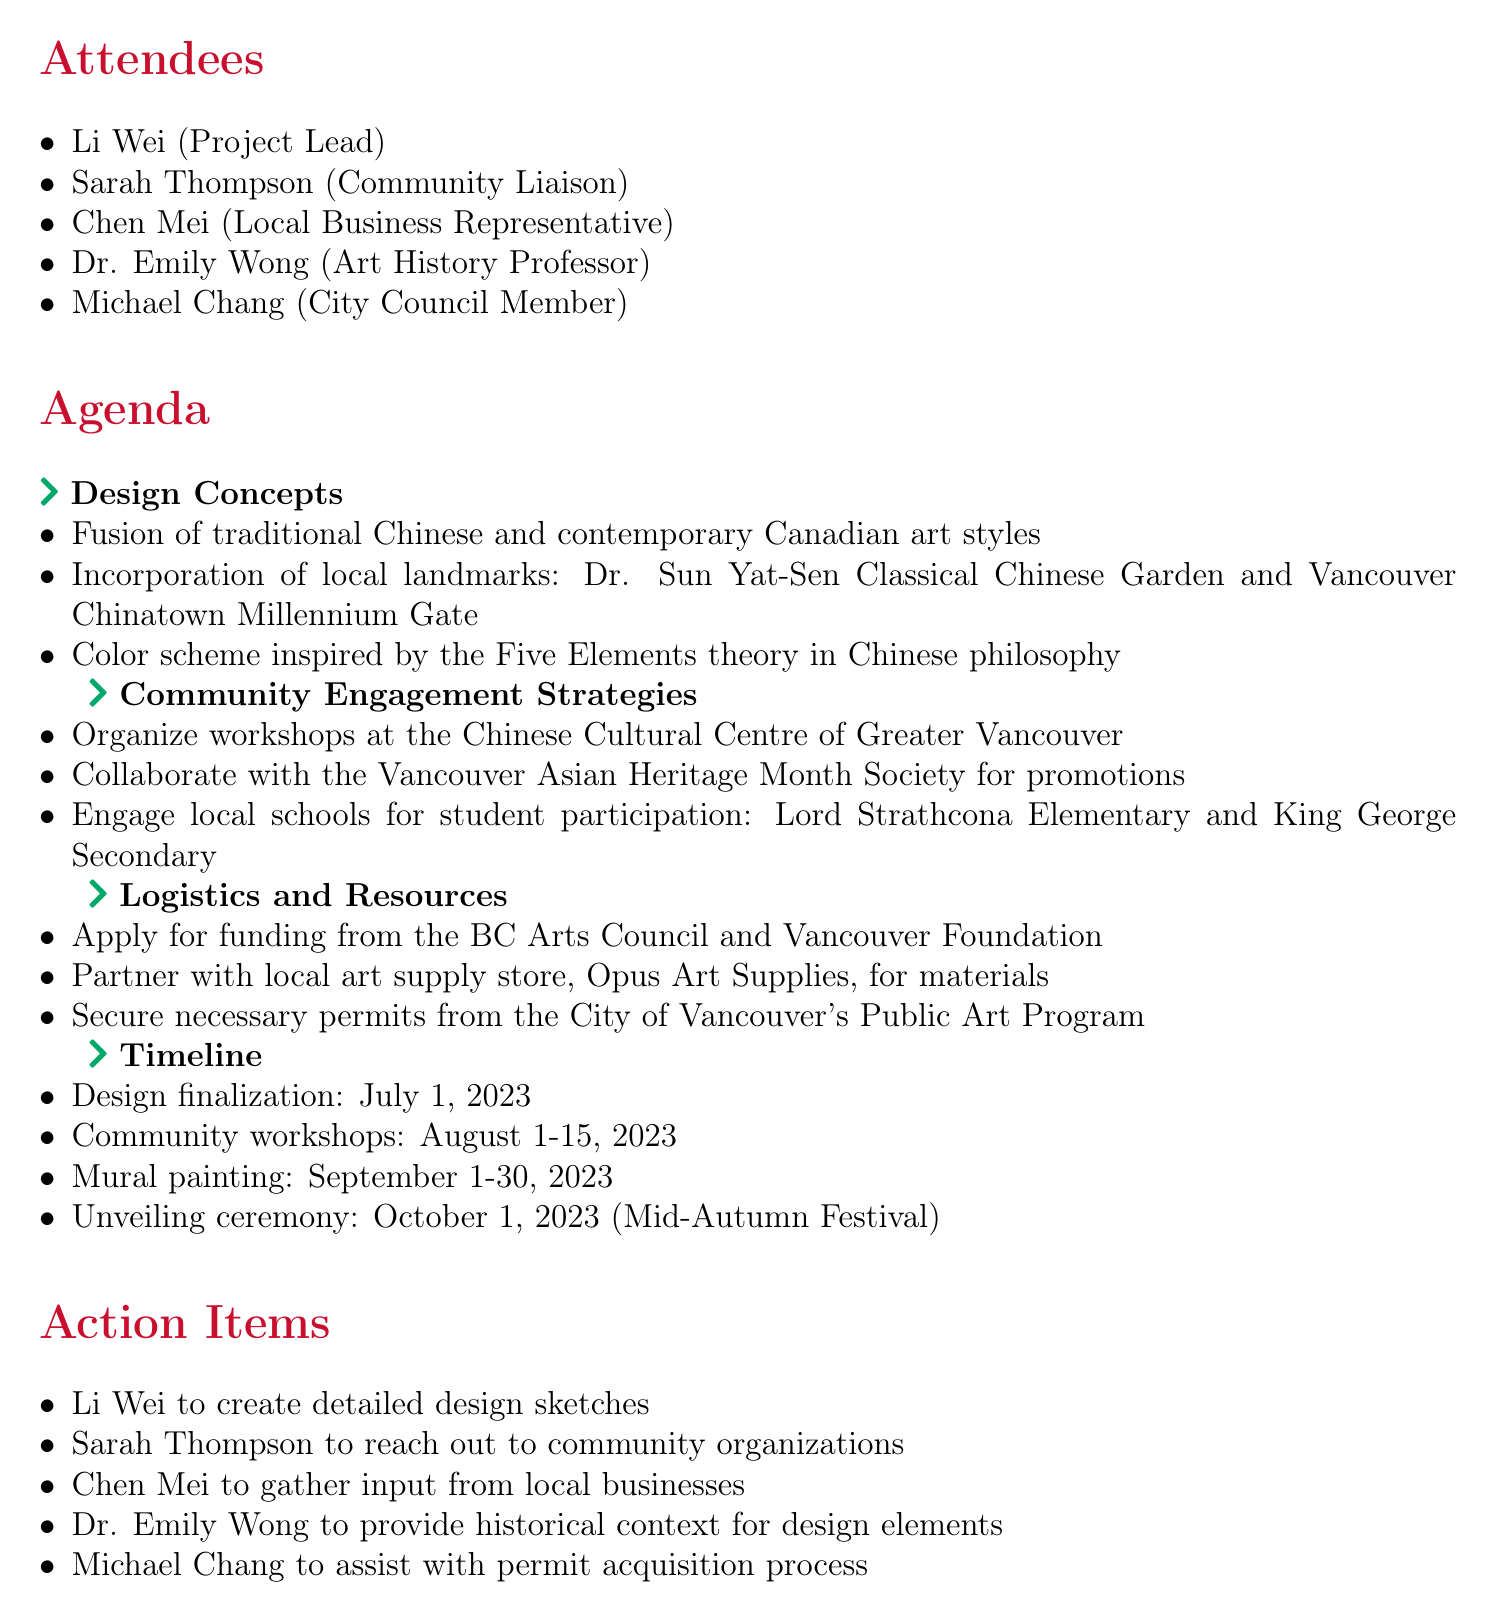What is the meeting date? The meeting date is mentioned in the document, which is May 15, 2023.
Answer: May 15, 2023 Who is the Project Lead? The document lists Li Wei as the Project Lead under the attendees section.
Answer: Li Wei What is one design concept? The design concepts include various elements, one of which is the fusion of traditional Chinese and contemporary Canadian art styles.
Answer: Fusion of traditional Chinese and contemporary Canadian art styles What is the timeline for mural painting? The timeline specifies that the mural painting is scheduled for September 1-30, 2023.
Answer: September 1-30, 2023 Which local school will participate? The document mentions Lord Strathcona Elementary as one of the schools for student participation.
Answer: Lord Strathcona Elementary How many attendees are there? The document lists a total of five attendees at the meeting.
Answer: Five What community organization is involved in promotions? The Vancouver Asian Heritage Month Society is mentioned as a collaborator for promotions in community engagement strategies.
Answer: Vancouver Asian Heritage Month Society Who is responsible for gathering input from local businesses? The action item indicates that Chen Mei is tasked with gathering input from local businesses.
Answer: Chen Mei When is the unveiling ceremony scheduled? The document states that the unveiling ceremony is planned for October 1, 2023.
Answer: October 1, 2023 